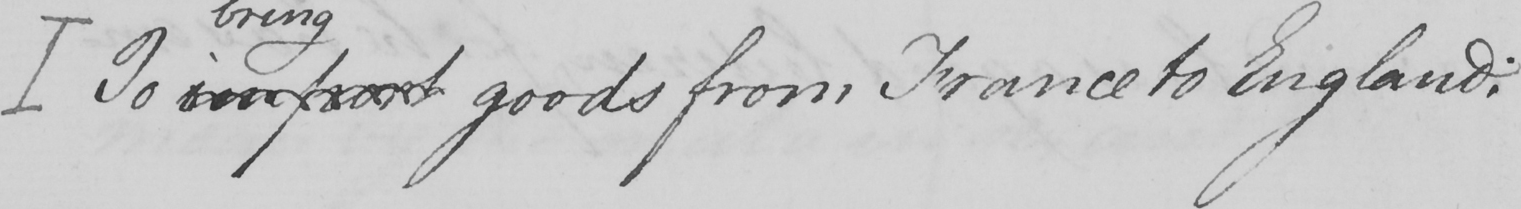Can you read and transcribe this handwriting? [ To import goods from France to England : 